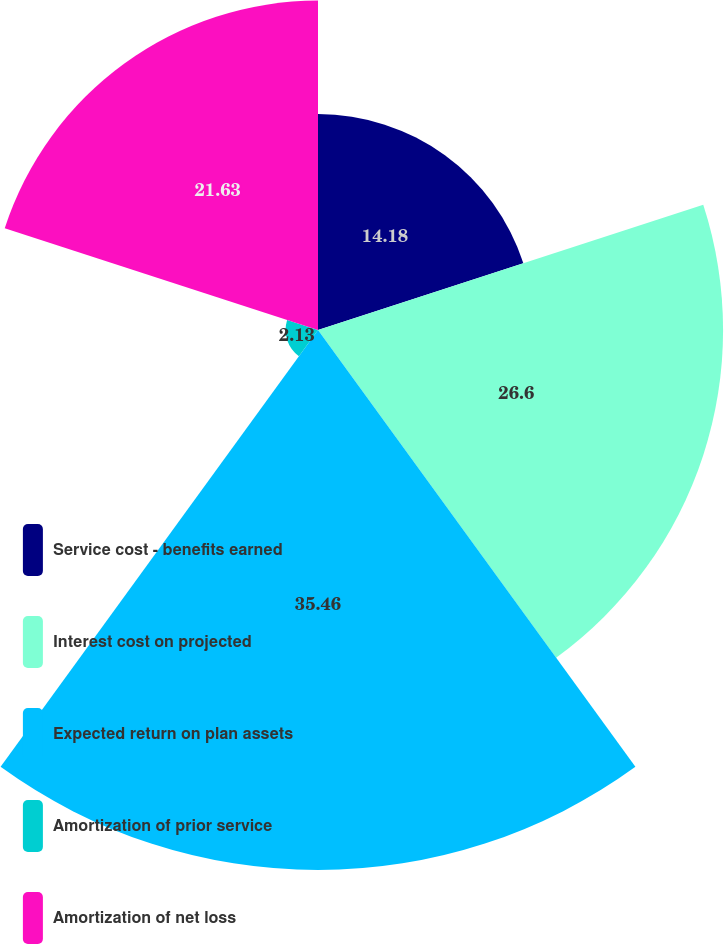Convert chart. <chart><loc_0><loc_0><loc_500><loc_500><pie_chart><fcel>Service cost - benefits earned<fcel>Interest cost on projected<fcel>Expected return on plan assets<fcel>Amortization of prior service<fcel>Amortization of net loss<nl><fcel>14.18%<fcel>26.6%<fcel>35.46%<fcel>2.13%<fcel>21.63%<nl></chart> 